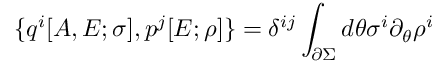Convert formula to latex. <formula><loc_0><loc_0><loc_500><loc_500>\{ q ^ { i } [ A , E ; \sigma ] , p ^ { j } [ E ; \rho ] \} = \delta ^ { i j } \int _ { \partial \Sigma } d \theta \sigma ^ { i } \partial _ { \theta } \rho ^ { i }</formula> 